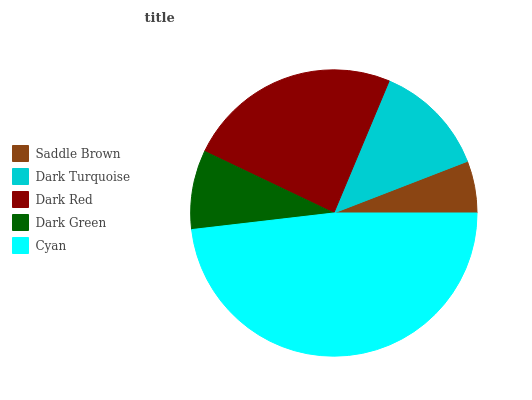Is Saddle Brown the minimum?
Answer yes or no. Yes. Is Cyan the maximum?
Answer yes or no. Yes. Is Dark Turquoise the minimum?
Answer yes or no. No. Is Dark Turquoise the maximum?
Answer yes or no. No. Is Dark Turquoise greater than Saddle Brown?
Answer yes or no. Yes. Is Saddle Brown less than Dark Turquoise?
Answer yes or no. Yes. Is Saddle Brown greater than Dark Turquoise?
Answer yes or no. No. Is Dark Turquoise less than Saddle Brown?
Answer yes or no. No. Is Dark Turquoise the high median?
Answer yes or no. Yes. Is Dark Turquoise the low median?
Answer yes or no. Yes. Is Dark Green the high median?
Answer yes or no. No. Is Cyan the low median?
Answer yes or no. No. 